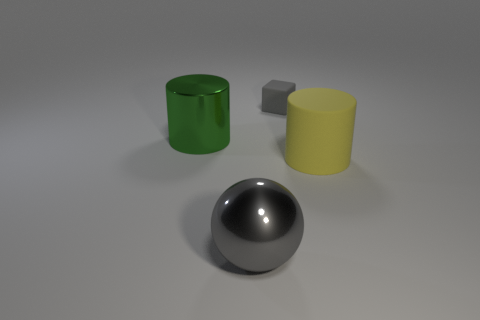Is there anything else that has the same size as the gray rubber cube?
Provide a succinct answer. No. Is there any other thing that has the same color as the metal cylinder?
Ensure brevity in your answer.  No. The tiny rubber thing is what color?
Provide a short and direct response. Gray. There is a object that is to the right of the tiny gray matte cube; is it the same size as the gray thing that is behind the green shiny cylinder?
Your answer should be very brief. No. Are there fewer small gray balls than big yellow cylinders?
Give a very brief answer. Yes. How many gray matte cubes are behind the small gray block?
Your answer should be compact. 0. What material is the ball?
Your response must be concise. Metal. Does the large shiny sphere have the same color as the small object?
Provide a succinct answer. Yes. Is the number of large gray balls that are behind the ball less than the number of small brown shiny spheres?
Provide a succinct answer. No. The big metal sphere on the left side of the gray rubber cube is what color?
Make the answer very short. Gray. 